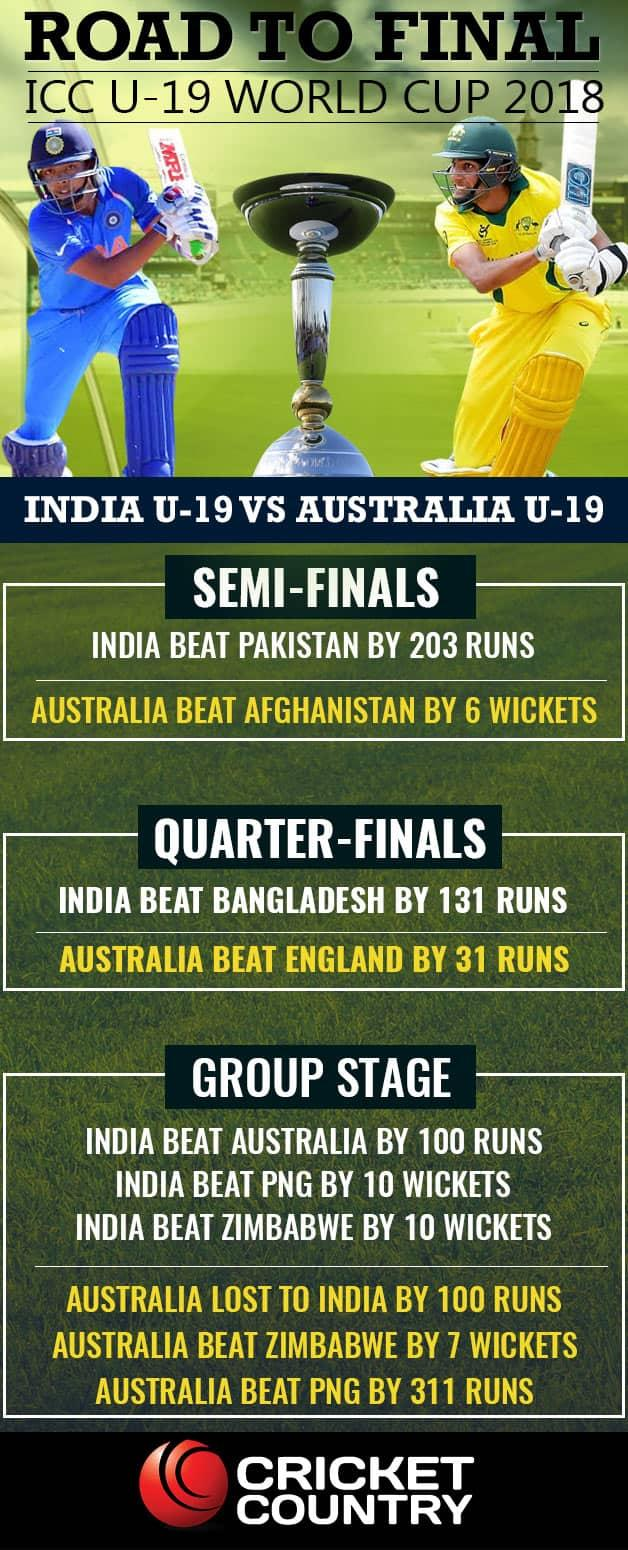Highlight a few significant elements in this photo. India has won against Pakistan by a significant margin with a large margin of runs. We have participated in 6 group stage matches, and we are ready for the next round. Australia has scored a significant victory over Papua New Guinea in their cricket match, winning by a significant number of runs. India has achieved a significant victory against several countries, including PNG and Zimbabwe, which demonstrates its superiority in the sport. India has won six matches. 